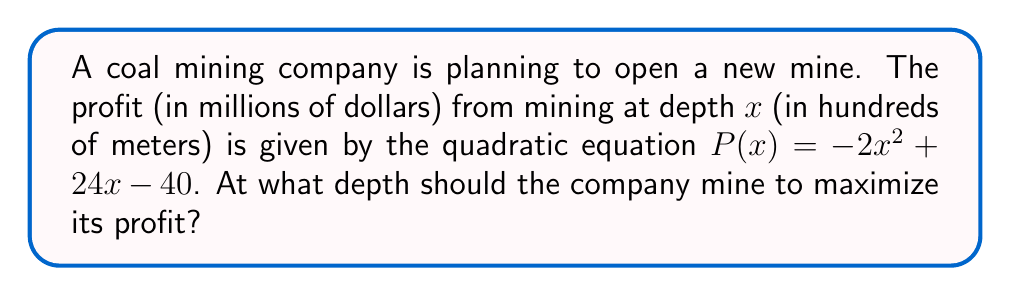Can you solve this math problem? To find the optimal mining depth, we need to find the maximum value of the quadratic function $P(x) = -2x^2 + 24x - 40$. This can be done by following these steps:

1) The quadratic function is in the form $f(x) = ax^2 + bx + c$, where $a = -2$, $b = 24$, and $c = -40$.

2) For a quadratic function, the x-coordinate of the vertex represents the value of x that maximizes (or minimizes) the function. The formula for this x-coordinate is $x = -\frac{b}{2a}$.

3) Substituting our values:

   $x = -\frac{24}{2(-2)} = -\frac{24}{-4} = 6$

4) To verify this is a maximum (not a minimum), we check that $a < 0$, which is true in this case ($a = -2$).

5) Therefore, the profit is maximized when $x = 6$.

6) Since $x$ represents depth in hundreds of meters, the optimal mining depth is 600 meters.

7) We can calculate the maximum profit by substituting $x = 6$ into the original equation:

   $P(6) = -2(6)^2 + 24(6) - 40 = -72 + 144 - 40 = 32$

Thus, the maximum profit is $32 million at a depth of 600 meters.
Answer: 600 meters 